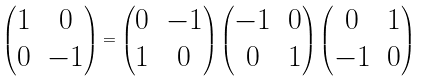Convert formula to latex. <formula><loc_0><loc_0><loc_500><loc_500>\begin{pmatrix} 1 & 0 \\ 0 & - 1 \\ \end{pmatrix} = \begin{pmatrix} 0 & - 1 \\ 1 & 0 \\ \end{pmatrix} \begin{pmatrix} - 1 & 0 \\ 0 & 1 \\ \end{pmatrix} \begin{pmatrix} 0 & 1 \\ - 1 & 0 \\ \end{pmatrix}</formula> 